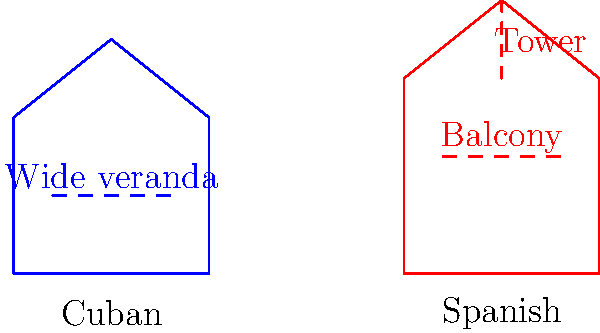Based on the architectural sketches provided, which feature is more commonly associated with traditional Spanish buildings and less likely to be found in Cuban architecture? To answer this question, let's analyze the key features of both Cuban and Spanish traditional architecture as depicted in the sketches:

1. Cuban architecture:
   - Simple, single-story structure
   - Wide veranda (highlighted in the sketch)
   - Sloped roof

2. Spanish architecture:
   - Multi-story structure
   - Balcony (highlighted in the sketch)
   - Tower or turret (highlighted in the sketch)
   - Steeper roof pitch

The most distinctive feature that sets Spanish architecture apart from Cuban architecture in this comparison is the tower or turret. This vertical element is a common characteristic of traditional Spanish buildings, particularly in residential architecture. It's often referred to as a "torreón" in Spanish.

Cuban architecture, influenced by its tropical climate and colonial history, typically favors wide verandas and single-story structures to promote air circulation and provide shade. Towers are not a common feature in traditional Cuban buildings.

Therefore, the tower or turret is the feature more commonly associated with traditional Spanish buildings and less likely to be found in Cuban architecture.
Answer: Tower or turret 